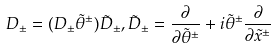<formula> <loc_0><loc_0><loc_500><loc_500>D _ { \pm } = ( D _ { \pm } \tilde { \theta } ^ { \pm } ) \tilde { D } _ { \pm } , \tilde { D } _ { \pm } = \frac { \partial } { \partial \tilde { \theta } ^ { \pm } } + i \tilde { \theta } ^ { \pm } \frac { \partial } { \partial \tilde { x } ^ { \pm } }</formula> 